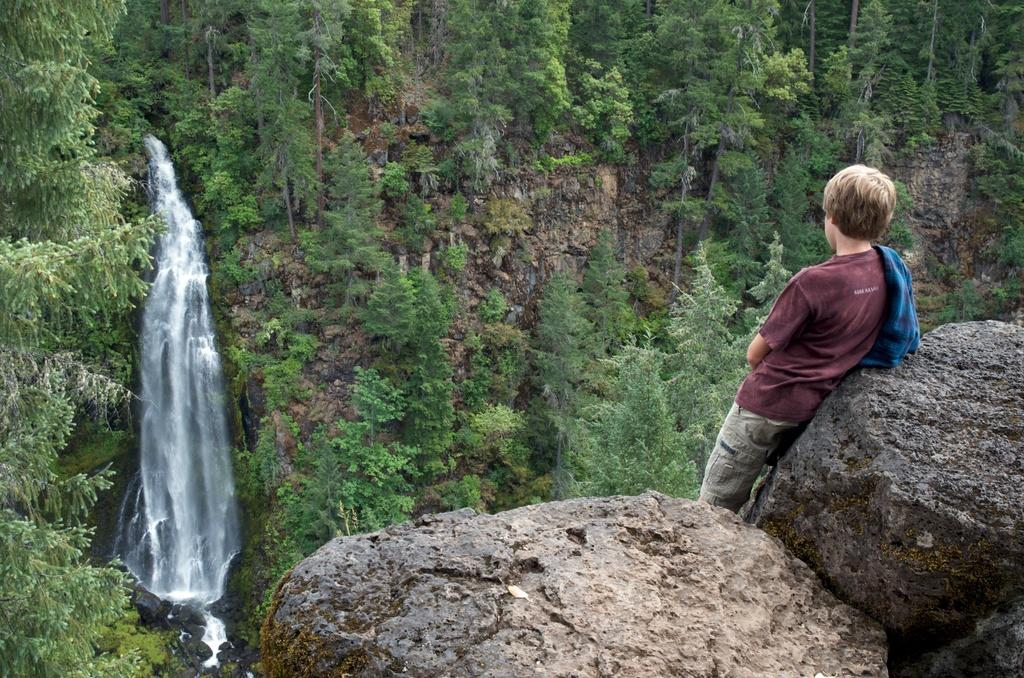What type of natural formations can be seen in the image? There are huge rocks in the image. Can you describe the person's position in relation to the rocks? There is a person standing behind the rocks. What other natural feature is present in the image? There is a waterfall in the image. What type of vegetation can be seen in the image? There are green trees in the image. Where is the shelf located in the image? There is no shelf present in the image. What type of stream can be seen in the image? There is no stream present in the image; it features a waterfall instead. 